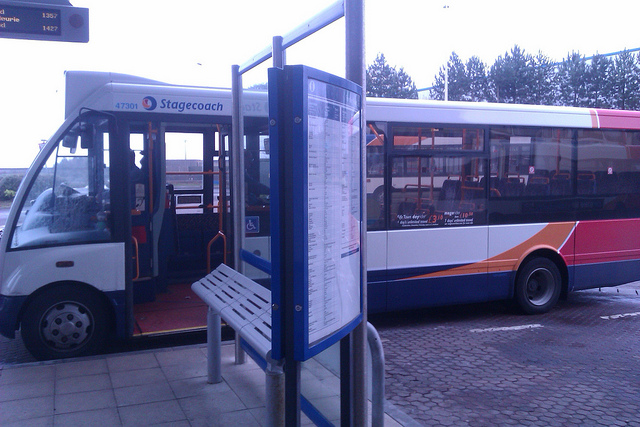Please transcribe the text information in this image. stagecoach 3 